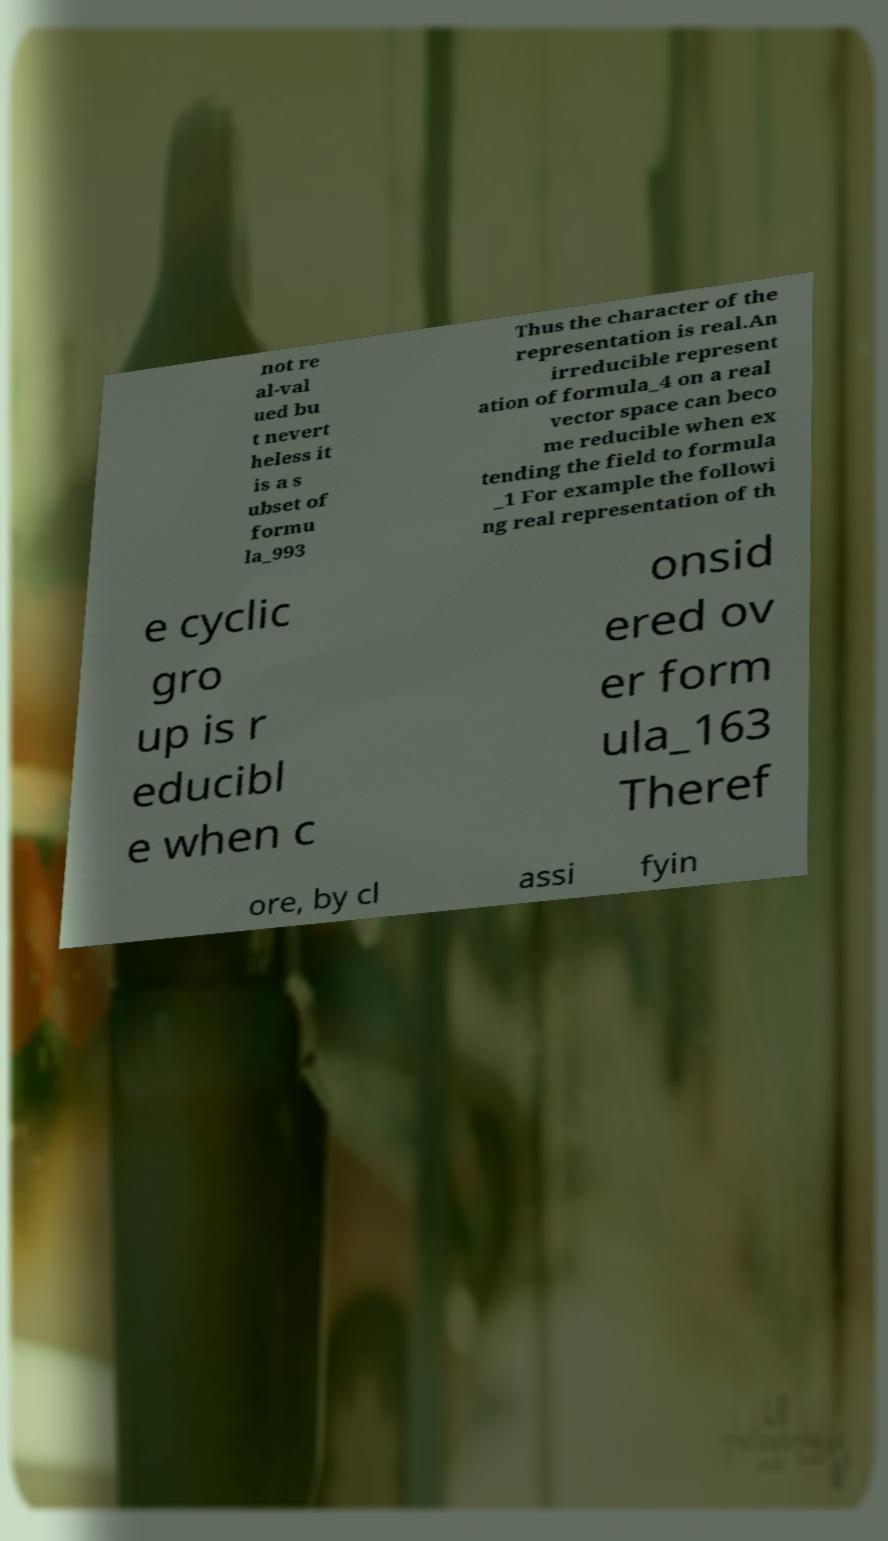What messages or text are displayed in this image? I need them in a readable, typed format. not re al-val ued bu t nevert heless it is a s ubset of formu la_993 Thus the character of the representation is real.An irreducible represent ation of formula_4 on a real vector space can beco me reducible when ex tending the field to formula _1 For example the followi ng real representation of th e cyclic gro up is r educibl e when c onsid ered ov er form ula_163 Theref ore, by cl assi fyin 